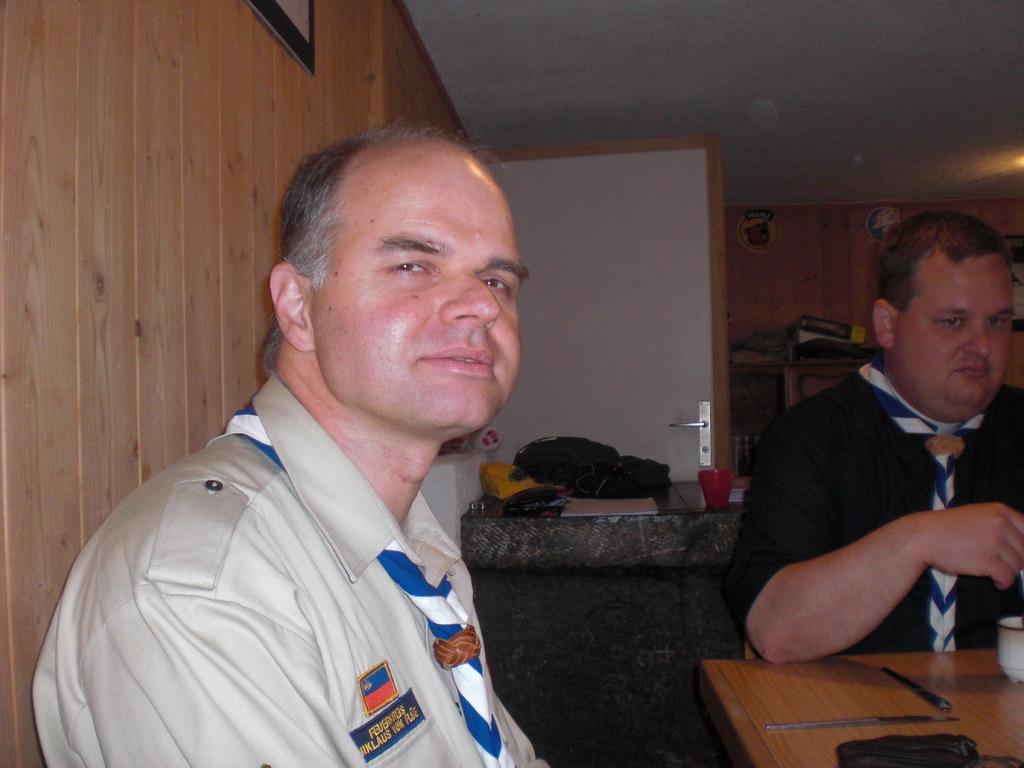How would you summarize this image in a sentence or two? In this image there are persons sitting. In the front the man is sitting and having some expression on his face. On the right side there is a man wearing black colour shirt is sitting and leaning on the table which is in front of him. On the table there is a cup and there are pens. In the background there is a door and there are objects which are red and black in colour. 